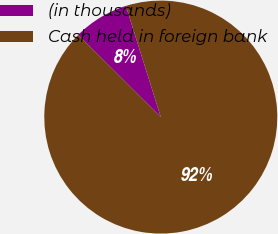Convert chart. <chart><loc_0><loc_0><loc_500><loc_500><pie_chart><fcel>(in thousands)<fcel>Cash held in foreign bank<nl><fcel>7.7%<fcel>92.3%<nl></chart> 